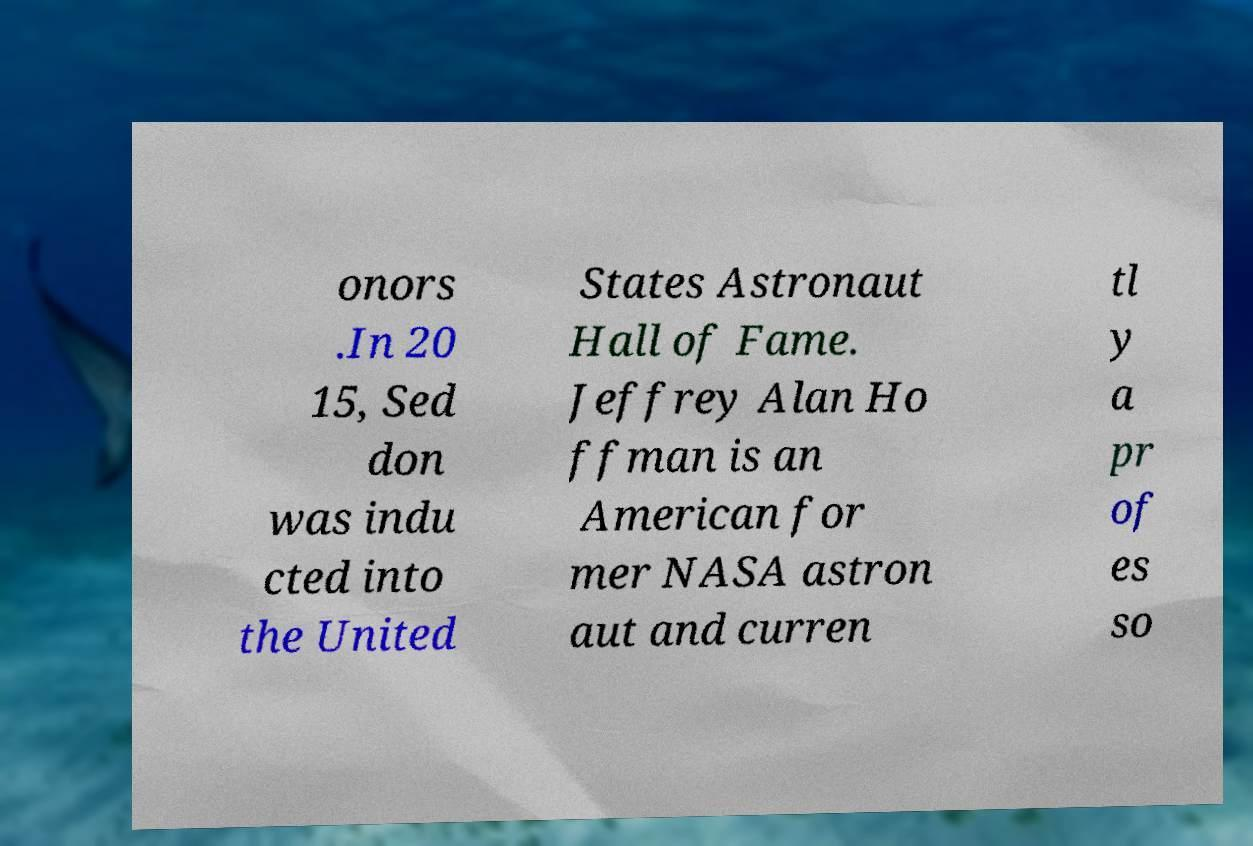There's text embedded in this image that I need extracted. Can you transcribe it verbatim? onors .In 20 15, Sed don was indu cted into the United States Astronaut Hall of Fame. Jeffrey Alan Ho ffman is an American for mer NASA astron aut and curren tl y a pr of es so 